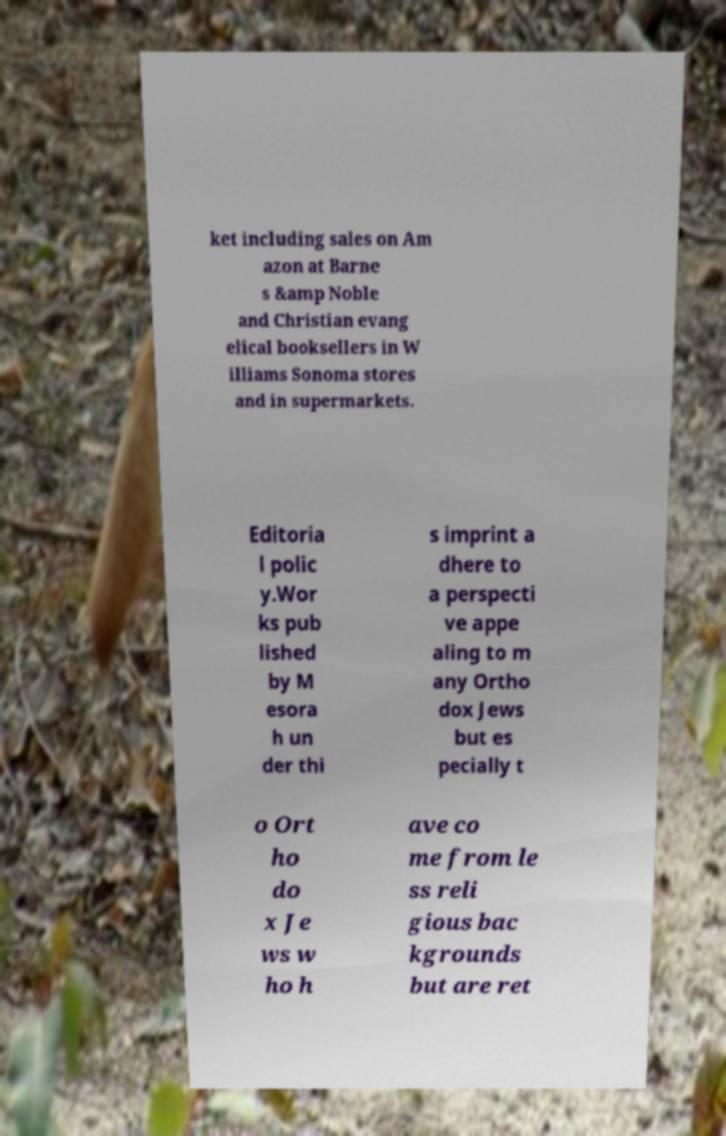Please identify and transcribe the text found in this image. ket including sales on Am azon at Barne s &amp Noble and Christian evang elical booksellers in W illiams Sonoma stores and in supermarkets. Editoria l polic y.Wor ks pub lished by M esora h un der thi s imprint a dhere to a perspecti ve appe aling to m any Ortho dox Jews but es pecially t o Ort ho do x Je ws w ho h ave co me from le ss reli gious bac kgrounds but are ret 